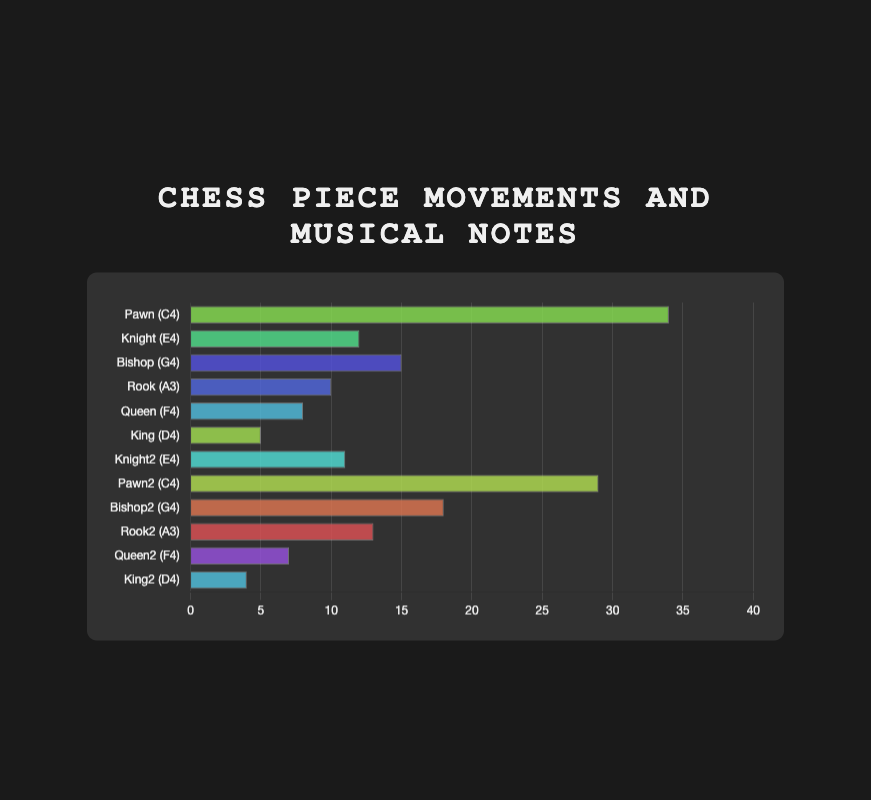Which chess piece has the highest movement frequency? The highest bar in the chart represents the movement frequency of each piece. The piece with the highest bar is the Pawn, corresponding to a frequency of 34.
Answer: Pawn How many chess pieces have a movement frequency higher than 15? By counting the bars that exceed the 15-mark on the x-axis, we see that the Pawn, Pawn2, and Bishop2 have movement frequencies higher than 15.
Answer: 3 Which musical note corresponds to the most frequent chess piece movement? Recognize that the Pawn has the highest movement frequency, and its corresponding musical note is C4.
Answer: C4 What is the combined movement frequency of the King and King2 pieces? Add the movement frequencies of King (5) and King2 (4) to obtain the total (5 + 4 = 9).
Answer: 9 Compare the movement frequencies of the Rook and Rook2 pieces. Which one is higher? By comparing the heights of the bars for Rook and Rook2, we see that Rook2 (13) has a higher movement frequency than Rook (10).
Answer: Rook2 What is the average movement frequency of all listed chess pieces? Sum the movement frequencies of all pieces (34 + 12 + 15 + 10 + 8 + 5 + 11 + 29 + 18 + 13 + 7 + 4 = 166) and divide by the number of pieces (12), giving an average of 166/12 = 13.83.
Answer: 13.83 Which piece has a matching movement frequency but different musical notes indicated twice? The Knight and Knight2 both have a movement frequency of 12 and 11 respectively, which matches in musical notes as E4.
Answer: Knight What is the difference in movement frequency between the highest and the lowest frequency chess piece? The highest frequency is 34 (Pawn) and the lowest is 4 (King2). The difference is calculated as 34 - 4 = 30.
Answer: 30 Which bar has the same color but represents different movement frequencies? Knight and Knight2 have the same hue as indicated, both representing different movement frequencies of 12 and 11 respectively.
Answer: Knight Which two pieces have movement frequencies summing up to 20? By adding the frequencies of different pieces, Bishop (15) + King (5) = 20, and Rook (10) + Knight (10) = 20. Verify the combinations using movements in separate bars.
Answer: Bishop and King 